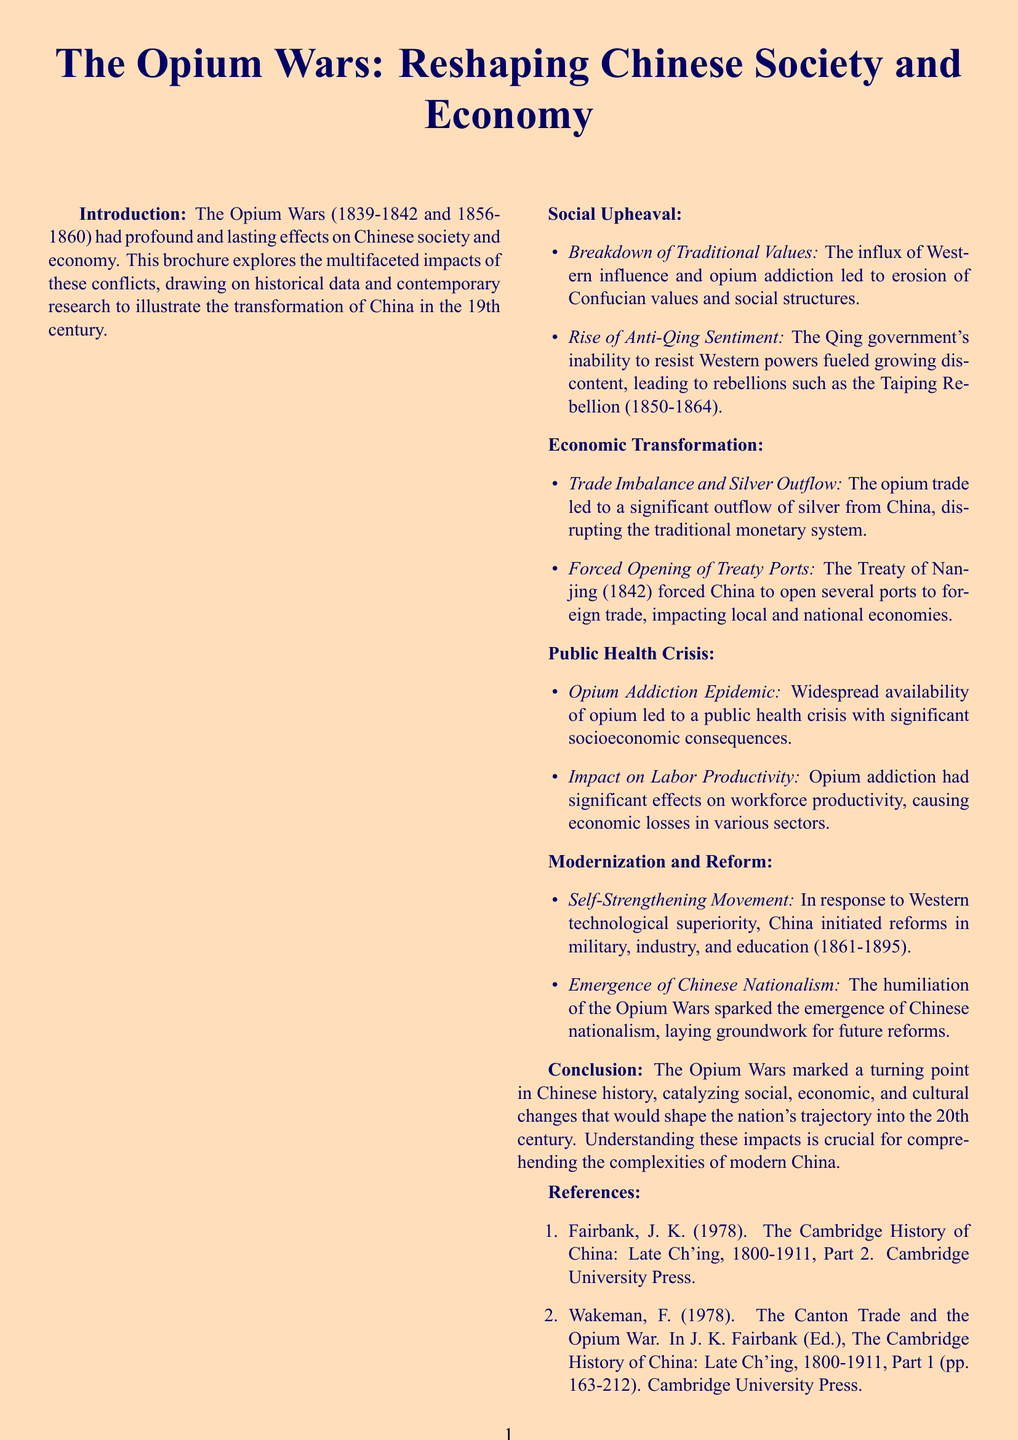What were the years of the Opium Wars? The years of the Opium Wars, as mentioned in the introduction, are 1839-1842 and 1856-1860.
Answer: 1839-1842 and 1856-1860 What is the title of the brochure? The first line of the document states the title of the brochure as "The Opium Wars: Reshaping Chinese Society and Economy."
Answer: The Opium Wars: Reshaping Chinese Society and Economy What major rebellion is mentioned in the context of Anti-Qing sentiment? The subsection regarding the rise of Anti-Qing sentiment highlights the Taiping Rebellion (1850-1864).
Answer: Taiping Rebellion What treaty forced China to open treaty ports? The document refers to the Treaty of Nanjing (1842) as the agreement that forced China to open ports.
Answer: Treaty of Nanjing What is one consequence of opium addiction mentioned in the brochure? The section on opium addiction addresses the public health crisis as a direct consequence of widespread opium availability.
Answer: Public health crisis Between which years did the Self-Strengthening Movement occur? The document specifies that the Self-Strengthening Movement took place from 1861 to 1895.
Answer: 1861-1895 What visual information supports understanding of silver outflow? The document includes a chart showing the silver outflow from China between 1820 and 1860 to illustrate this point.
Answer: Chart showing silver outflow Which image is included in the section on Breakdown of Traditional Values? The brochure contains an illustration of a Chinese opium den in the 1850s related to this section.
Answer: Illustration of a Chinese opium den in the 1850s What does the composite index graph in the conclusion represent? The composite index graph illustrates social and economic changes in China from 1830 to 1900, as stated in the conclusion.
Answer: Social and economic changes in China from 1830 to 1900 